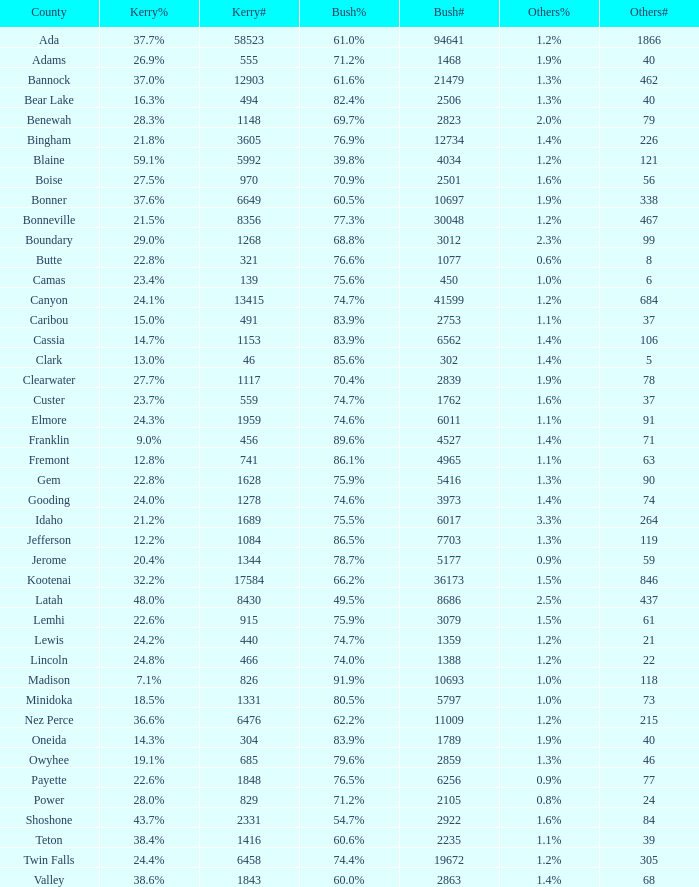What is the number of people who voted for kerry in the county with 8 votes for other participants? 321.0. 